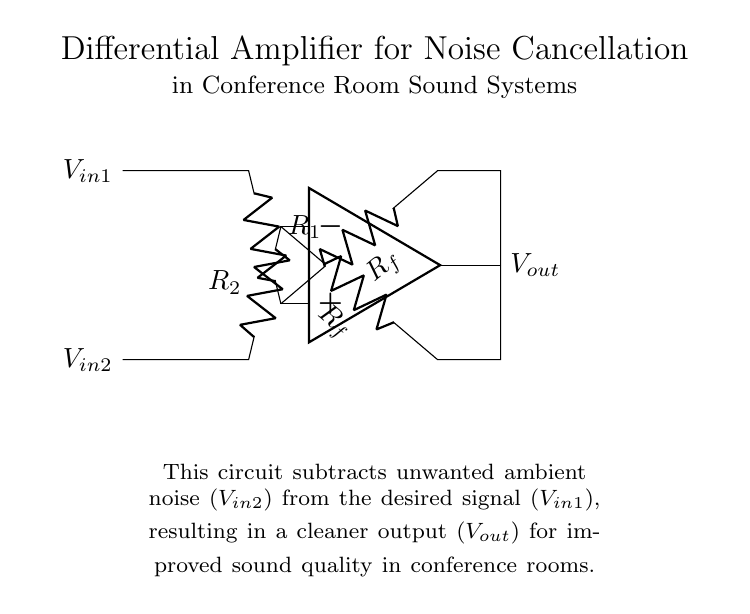What type of amplifier is shown in the circuit? The circuit is specifically labeled as a differential amplifier. This is indicated by the structure of the op-amp and the configuration of inputs and feedback paths.
Answer: Differential amplifier What do the resistors R1 and R2 configure in this circuit? R1 and R2 are the input resistors for the differential amplifier. They determine the gain and help in subtracting one input signal from the other to isolate the desired signal.
Answer: Input resistors What is the main purpose of this circuit? The main purpose is to subtract unwanted noise from the desired audio signal in conference room environments, improving sound clarity. This is clearly stated in the explanation section of the circuit diagram.
Answer: Noise cancellation How does Rf impact the output of the differential amplifier? Rf is the feedback resistor that influences the gain of the amplifier. A higher value of Rf increases the gain, affecting the sensitivity of the circuit to input signals. Therefore, it directly impacts the output voltage based on the input and feedback settings.
Answer: Feedback gain What does the output voltage represent in this circuit? The output voltage represents the amplified difference between the two input signals. It's derived from the input signals' difference after noise cancellation, resulting in a cleaner signal for the sound system.
Answer: Amplified difference Which component in this circuit is responsible for noise cancellation? The differential amplifier itself is responsible for noise cancellation as it processes the two input signals in such a way that unwanted noise is subtracted from the desired signal before reaching the output.
Answer: Differential amplifier 